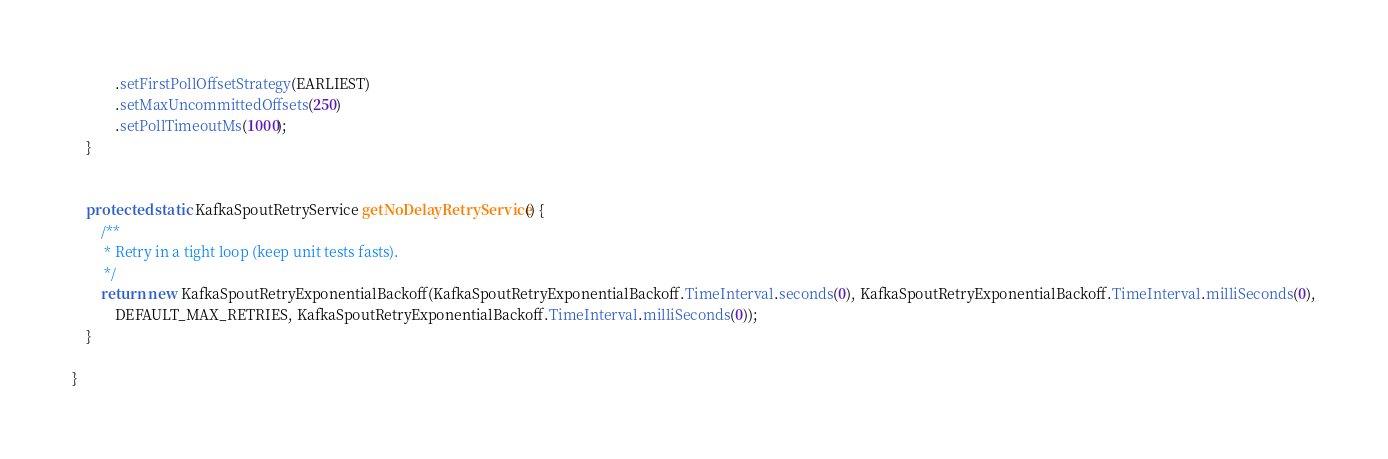Convert code to text. <code><loc_0><loc_0><loc_500><loc_500><_Java_>            .setFirstPollOffsetStrategy(EARLIEST)
            .setMaxUncommittedOffsets(250)
            .setPollTimeoutMs(1000);
    }


    protected static KafkaSpoutRetryService getNoDelayRetryService() {
        /**
         * Retry in a tight loop (keep unit tests fasts).
         */
        return new KafkaSpoutRetryExponentialBackoff(KafkaSpoutRetryExponentialBackoff.TimeInterval.seconds(0), KafkaSpoutRetryExponentialBackoff.TimeInterval.milliSeconds(0),
            DEFAULT_MAX_RETRIES, KafkaSpoutRetryExponentialBackoff.TimeInterval.milliSeconds(0));
    }

}
</code> 